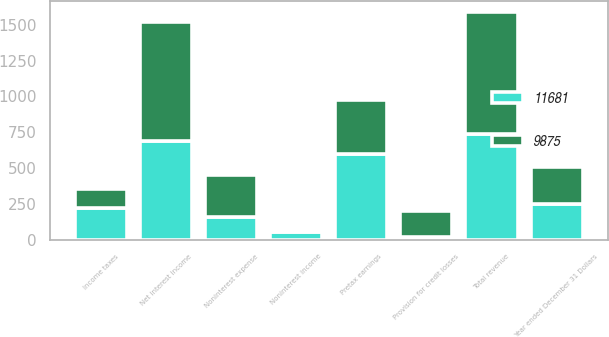<chart> <loc_0><loc_0><loc_500><loc_500><stacked_bar_chart><ecel><fcel>Year ended December 31 Dollars<fcel>Net interest income<fcel>Noninterest income<fcel>Total revenue<fcel>Provision for credit losses<fcel>Noninterest expense<fcel>Pretax earnings<fcel>Income taxes<nl><fcel>11681<fcel>254<fcel>689<fcel>53<fcel>742<fcel>21<fcel>163<fcel>600<fcel>221<nl><fcel>9875<fcel>254<fcel>830<fcel>13<fcel>843<fcel>181<fcel>287<fcel>375<fcel>138<nl></chart> 